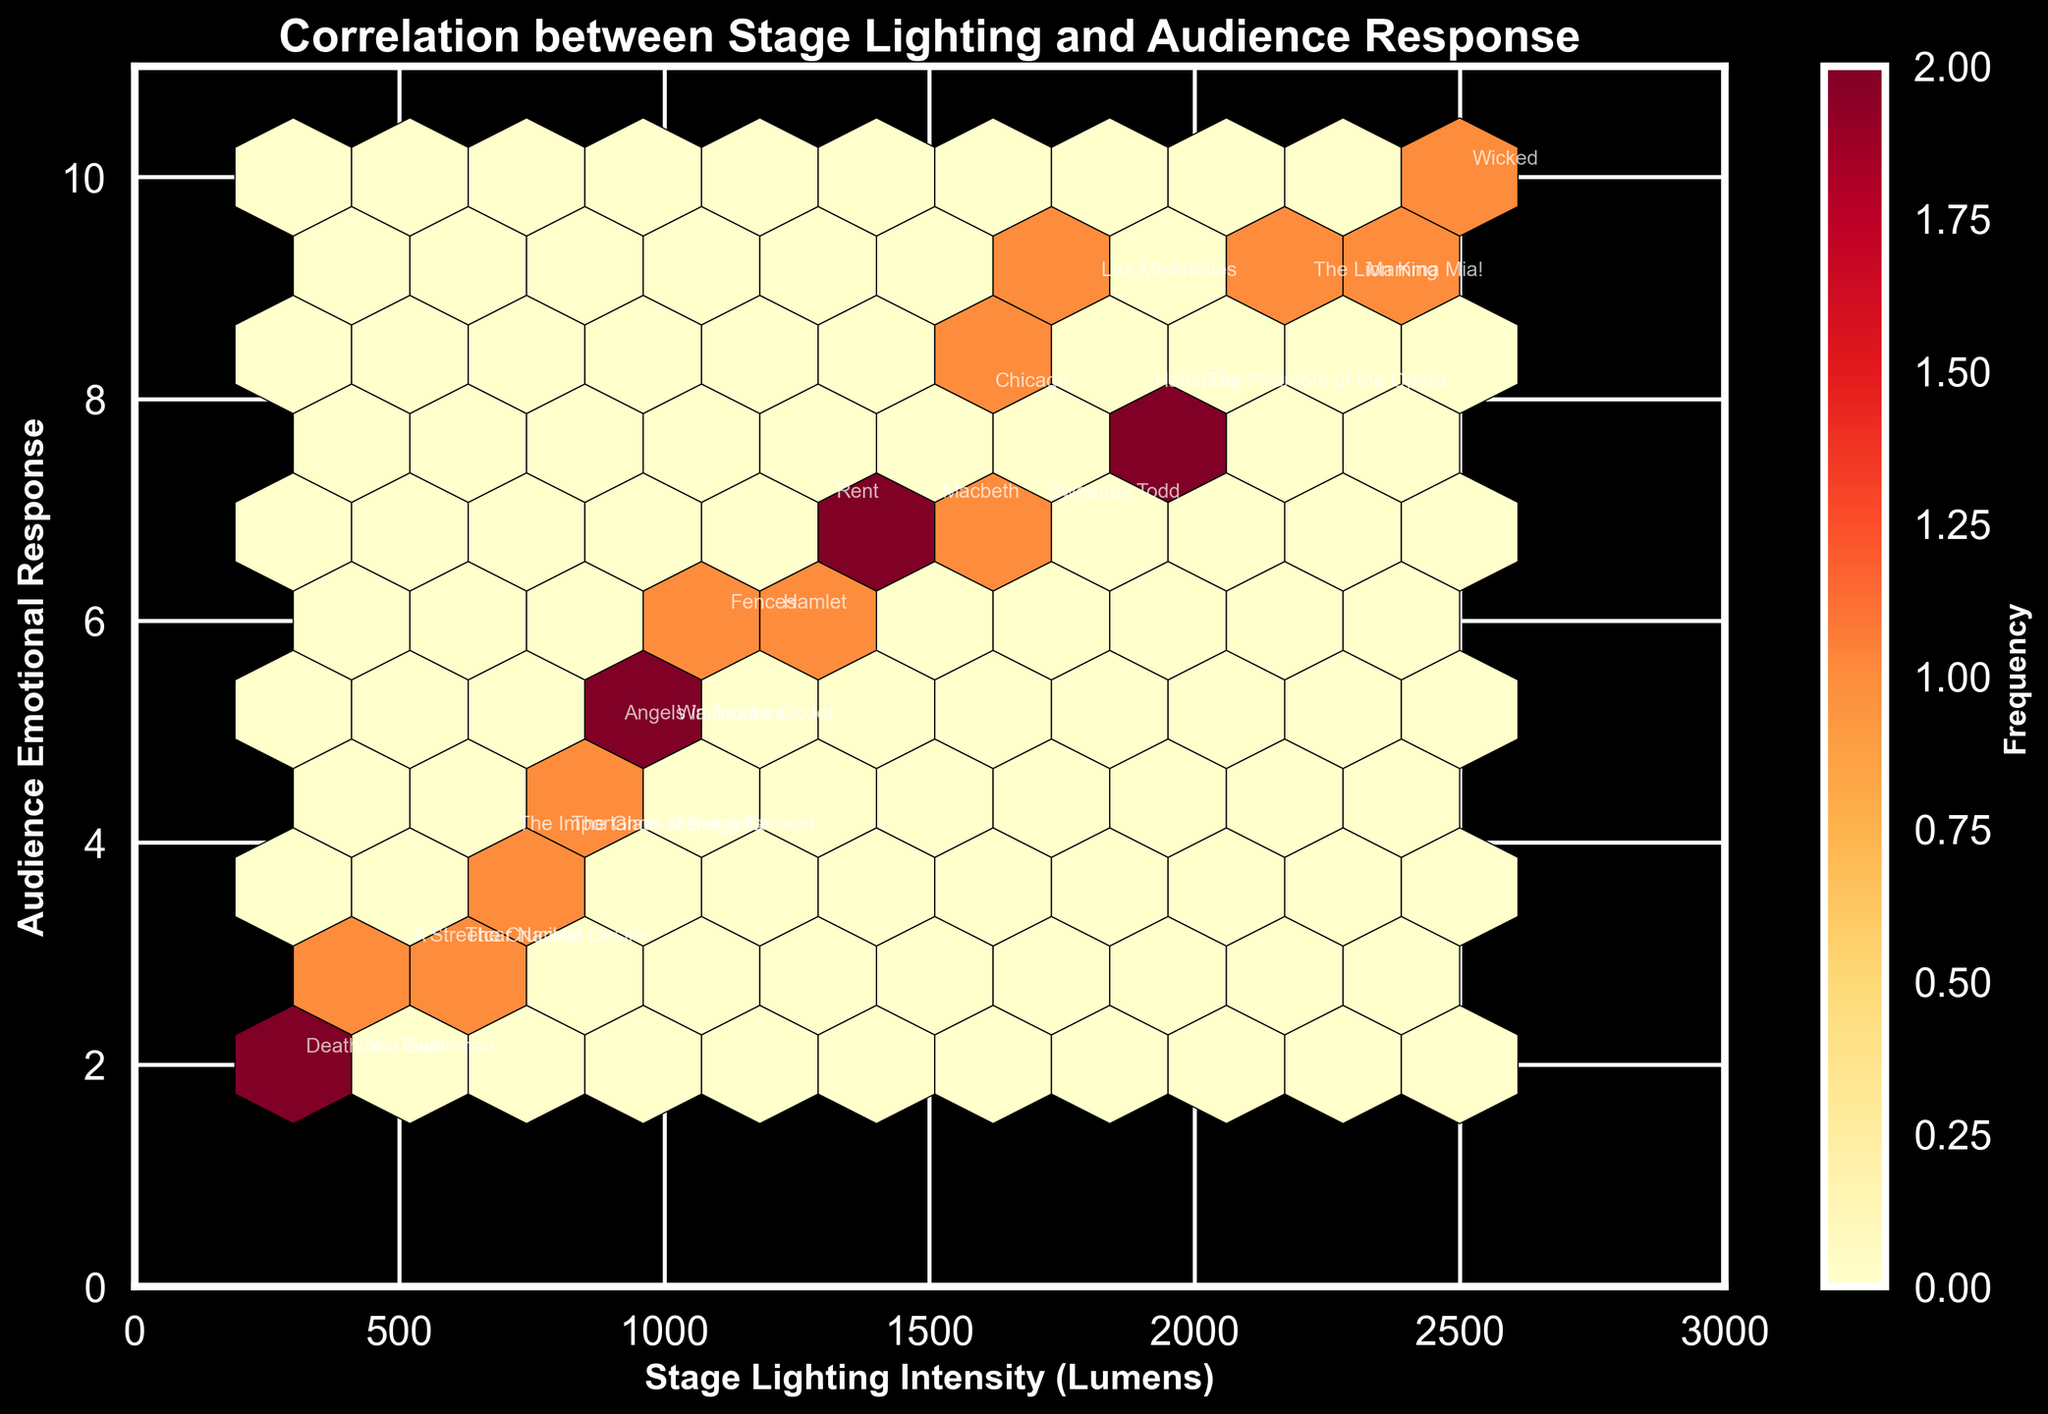What is the title of the plot? The plot's title is located at the top of the figure. It usually provides a summary of the contents. In this case, the title indicates the relationship between stage lighting and audience response.
Answer: Correlation between Stage Lighting and Audience Response How many theatrical productions are represented in the plot? Each point in the plot represents one theatrical production. By counting the total points or annotations, you can determine the number of productions.
Answer: 20 What is the x-axis label, and what does it represent? The x-axis label is typically located below the horizontal axis and describes what the axis measures. Here, it represents the intensity of stage lighting.
Answer: Stage Lighting Intensity (Lumens) What is the y-axis label, and what does it represent? The y-axis label is usually found beside the vertical axis and explains what the axis measures. In this plot, it represents the audience's emotional response on a scale of 1 to 10.
Answer: Audience Emotional Response Which production has the highest stage lighting intensity, and what is the corresponding emotional response? Locate the data point with the highest value on the x-axis and check the annotation for the production name. Then, read the corresponding y-value for the emotional response.
Answer: Wicked, 10 Which production has the lowest audience emotional response, and what is the corresponding stage lighting intensity? Identify the data point with the lowest value on the y-axis and check the annotation for the production name. Then, read the corresponding x-value for the stage lighting intensity.
Answer: Death of a Salesman, 300 Lumens Is there a noticeable trend between stage lighting intensity and audience emotional response? To determine if there’s a trend, observe if there is a general increase or decrease in audience response with changes in stage lighting intensity. Look for a pattern among the hexagons' density.
Answer: Yes, increasing lighting intensity seems to be associated with higher emotional responses Which production falls closest to the median stage lighting intensity? To find the median, list the stage lighting intensities numerically and identify the middle value. Locate the production name at this intensity level in the plot.
Answer: The Importance of Being Earnest Which production has the largest difference between its stage lighting intensity and audience emotional response? Determine the difference between the x (stage lighting) and y (emotional response) values for each data point. Identify the largest difference and the corresponding production name.
Answer: Wicked has the largest difference (2400) How are the data points distributed in terms of density? Hexbin plots use color to indicate the density of data points in each bin. Identify regions with the most densely populated hexagons to understand the data distribution.
Answer: More densely clustered within the range of 1000-2000 Lumens and emotional response between 5-9 